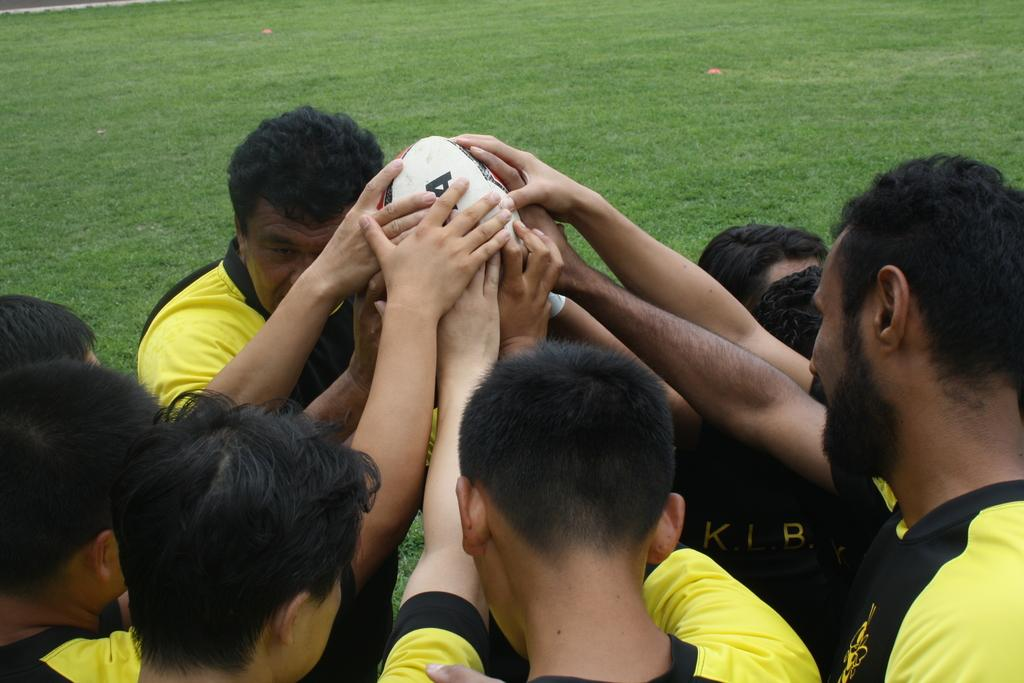What can be seen in the image involving people? There are players in the image. What are the players wearing? The players are wearing yellow T-shirts. What object are the players holding? The players are holding a white ball. What type of surface is visible in the background of the image? There is a grass surface in the background of the image. What type of meal are the players eating in the image? There is no meal present in the image; the players are holding a white ball. Can you describe the tramp in the image? There is no tramp present in the image; the main subjects are the players and the white ball. 